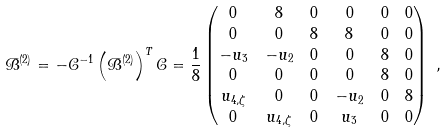<formula> <loc_0><loc_0><loc_500><loc_500>\mathcal { B } ^ { ( 2 ) } & = - \mathcal { C } ^ { - 1 } \left ( \mathcal { B } ^ { ( 2 ) } \right ) ^ { T } \mathcal { C } = \frac { 1 } { 8 } \begin{pmatrix} 0 & 8 & 0 & 0 & 0 & 0 \\ 0 & 0 & 8 & 8 & 0 & 0 \\ - u _ { 3 } & - u _ { 2 } & 0 & 0 & 8 & 0 \\ 0 & 0 & 0 & 0 & 8 & 0 \\ u _ { 4 , \zeta } & 0 & 0 & - u _ { 2 } & 0 & 8 \\ 0 & u _ { 4 , \zeta } & 0 & u _ { 3 } & 0 & 0 \\ \end{pmatrix} \ ,</formula> 